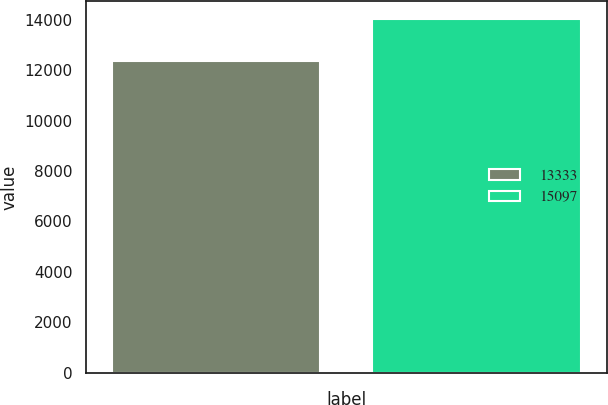Convert chart. <chart><loc_0><loc_0><loc_500><loc_500><bar_chart><fcel>13333<fcel>15097<nl><fcel>12355<fcel>14040<nl></chart> 